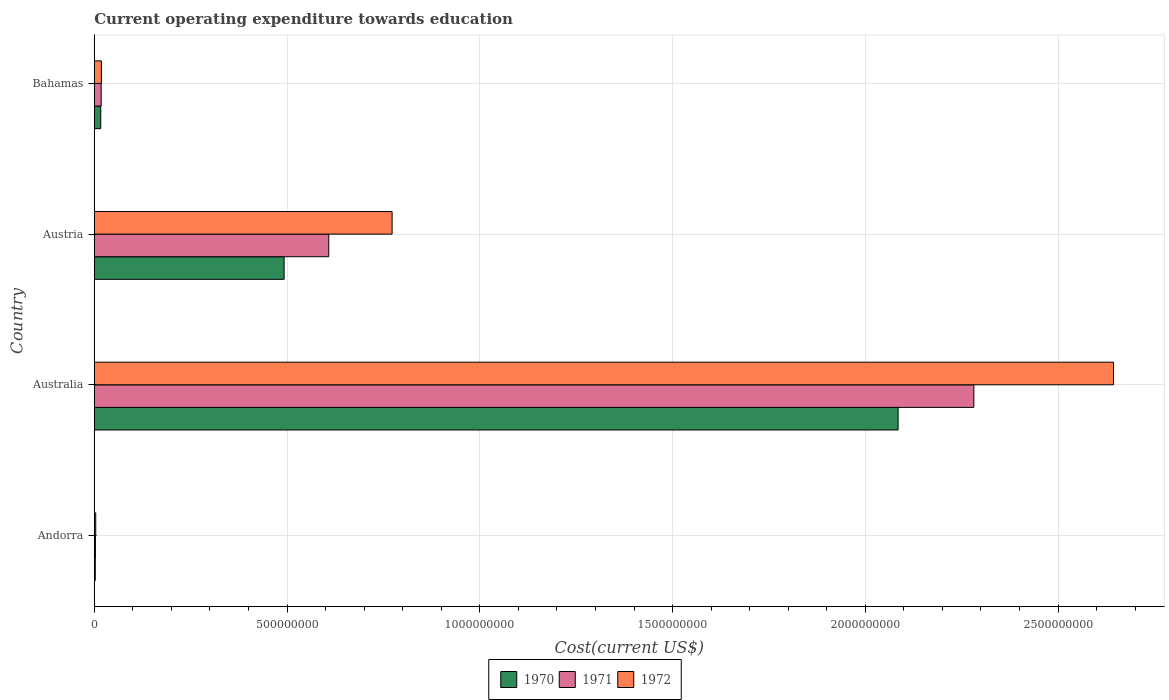How many different coloured bars are there?
Give a very brief answer. 3. How many groups of bars are there?
Your answer should be compact. 4. Are the number of bars per tick equal to the number of legend labels?
Your answer should be compact. Yes. Are the number of bars on each tick of the Y-axis equal?
Give a very brief answer. Yes. How many bars are there on the 4th tick from the top?
Your answer should be compact. 3. What is the label of the 1st group of bars from the top?
Your answer should be very brief. Bahamas. What is the expenditure towards education in 1971 in Australia?
Provide a succinct answer. 2.28e+09. Across all countries, what is the maximum expenditure towards education in 1972?
Your answer should be very brief. 2.64e+09. Across all countries, what is the minimum expenditure towards education in 1971?
Keep it short and to the point. 2.95e+06. In which country was the expenditure towards education in 1972 maximum?
Give a very brief answer. Australia. In which country was the expenditure towards education in 1972 minimum?
Your answer should be very brief. Andorra. What is the total expenditure towards education in 1972 in the graph?
Keep it short and to the point. 3.44e+09. What is the difference between the expenditure towards education in 1970 in Andorra and that in Australia?
Your answer should be compact. -2.08e+09. What is the difference between the expenditure towards education in 1970 in Bahamas and the expenditure towards education in 1972 in Australia?
Provide a short and direct response. -2.63e+09. What is the average expenditure towards education in 1970 per country?
Ensure brevity in your answer.  6.49e+08. What is the difference between the expenditure towards education in 1970 and expenditure towards education in 1971 in Austria?
Offer a terse response. -1.16e+08. In how many countries, is the expenditure towards education in 1971 greater than 1800000000 US$?
Provide a short and direct response. 1. What is the ratio of the expenditure towards education in 1972 in Andorra to that in Australia?
Provide a short and direct response. 0. Is the expenditure towards education in 1972 in Andorra less than that in Austria?
Your answer should be compact. Yes. What is the difference between the highest and the second highest expenditure towards education in 1971?
Your response must be concise. 1.67e+09. What is the difference between the highest and the lowest expenditure towards education in 1972?
Provide a succinct answer. 2.64e+09. What does the 1st bar from the bottom in Austria represents?
Your answer should be compact. 1970. How many countries are there in the graph?
Offer a very short reply. 4. What is the difference between two consecutive major ticks on the X-axis?
Give a very brief answer. 5.00e+08. Are the values on the major ticks of X-axis written in scientific E-notation?
Your answer should be very brief. No. Does the graph contain grids?
Provide a short and direct response. Yes. How many legend labels are there?
Make the answer very short. 3. How are the legend labels stacked?
Your answer should be compact. Horizontal. What is the title of the graph?
Your answer should be very brief. Current operating expenditure towards education. Does "1994" appear as one of the legend labels in the graph?
Your answer should be compact. No. What is the label or title of the X-axis?
Make the answer very short. Cost(current US$). What is the Cost(current US$) of 1970 in Andorra?
Give a very brief answer. 2.59e+06. What is the Cost(current US$) in 1971 in Andorra?
Offer a very short reply. 2.95e+06. What is the Cost(current US$) of 1972 in Andorra?
Provide a succinct answer. 3.74e+06. What is the Cost(current US$) of 1970 in Australia?
Provide a succinct answer. 2.09e+09. What is the Cost(current US$) of 1971 in Australia?
Your answer should be compact. 2.28e+09. What is the Cost(current US$) in 1972 in Australia?
Provide a succinct answer. 2.64e+09. What is the Cost(current US$) of 1970 in Austria?
Your response must be concise. 4.92e+08. What is the Cost(current US$) of 1971 in Austria?
Offer a terse response. 6.08e+08. What is the Cost(current US$) of 1972 in Austria?
Make the answer very short. 7.73e+08. What is the Cost(current US$) in 1970 in Bahamas?
Your answer should be compact. 1.68e+07. What is the Cost(current US$) in 1971 in Bahamas?
Your answer should be very brief. 1.79e+07. What is the Cost(current US$) in 1972 in Bahamas?
Provide a succinct answer. 1.85e+07. Across all countries, what is the maximum Cost(current US$) of 1970?
Ensure brevity in your answer.  2.09e+09. Across all countries, what is the maximum Cost(current US$) of 1971?
Your answer should be compact. 2.28e+09. Across all countries, what is the maximum Cost(current US$) in 1972?
Offer a terse response. 2.64e+09. Across all countries, what is the minimum Cost(current US$) in 1970?
Ensure brevity in your answer.  2.59e+06. Across all countries, what is the minimum Cost(current US$) of 1971?
Offer a very short reply. 2.95e+06. Across all countries, what is the minimum Cost(current US$) in 1972?
Ensure brevity in your answer.  3.74e+06. What is the total Cost(current US$) of 1970 in the graph?
Provide a succinct answer. 2.60e+09. What is the total Cost(current US$) of 1971 in the graph?
Make the answer very short. 2.91e+09. What is the total Cost(current US$) of 1972 in the graph?
Your answer should be compact. 3.44e+09. What is the difference between the Cost(current US$) in 1970 in Andorra and that in Australia?
Your response must be concise. -2.08e+09. What is the difference between the Cost(current US$) in 1971 in Andorra and that in Australia?
Give a very brief answer. -2.28e+09. What is the difference between the Cost(current US$) in 1972 in Andorra and that in Australia?
Offer a very short reply. -2.64e+09. What is the difference between the Cost(current US$) of 1970 in Andorra and that in Austria?
Offer a very short reply. -4.90e+08. What is the difference between the Cost(current US$) of 1971 in Andorra and that in Austria?
Offer a very short reply. -6.05e+08. What is the difference between the Cost(current US$) of 1972 in Andorra and that in Austria?
Your response must be concise. -7.69e+08. What is the difference between the Cost(current US$) in 1970 in Andorra and that in Bahamas?
Your answer should be very brief. -1.42e+07. What is the difference between the Cost(current US$) in 1971 in Andorra and that in Bahamas?
Offer a very short reply. -1.50e+07. What is the difference between the Cost(current US$) of 1972 in Andorra and that in Bahamas?
Give a very brief answer. -1.47e+07. What is the difference between the Cost(current US$) of 1970 in Australia and that in Austria?
Keep it short and to the point. 1.59e+09. What is the difference between the Cost(current US$) in 1971 in Australia and that in Austria?
Make the answer very short. 1.67e+09. What is the difference between the Cost(current US$) of 1972 in Australia and that in Austria?
Your response must be concise. 1.87e+09. What is the difference between the Cost(current US$) of 1970 in Australia and that in Bahamas?
Provide a short and direct response. 2.07e+09. What is the difference between the Cost(current US$) of 1971 in Australia and that in Bahamas?
Provide a short and direct response. 2.26e+09. What is the difference between the Cost(current US$) of 1972 in Australia and that in Bahamas?
Your response must be concise. 2.63e+09. What is the difference between the Cost(current US$) of 1970 in Austria and that in Bahamas?
Make the answer very short. 4.76e+08. What is the difference between the Cost(current US$) of 1971 in Austria and that in Bahamas?
Provide a short and direct response. 5.90e+08. What is the difference between the Cost(current US$) of 1972 in Austria and that in Bahamas?
Offer a very short reply. 7.54e+08. What is the difference between the Cost(current US$) in 1970 in Andorra and the Cost(current US$) in 1971 in Australia?
Your answer should be very brief. -2.28e+09. What is the difference between the Cost(current US$) in 1970 in Andorra and the Cost(current US$) in 1972 in Australia?
Offer a very short reply. -2.64e+09. What is the difference between the Cost(current US$) in 1971 in Andorra and the Cost(current US$) in 1972 in Australia?
Provide a succinct answer. -2.64e+09. What is the difference between the Cost(current US$) of 1970 in Andorra and the Cost(current US$) of 1971 in Austria?
Offer a terse response. -6.06e+08. What is the difference between the Cost(current US$) in 1970 in Andorra and the Cost(current US$) in 1972 in Austria?
Give a very brief answer. -7.70e+08. What is the difference between the Cost(current US$) in 1971 in Andorra and the Cost(current US$) in 1972 in Austria?
Keep it short and to the point. -7.70e+08. What is the difference between the Cost(current US$) in 1970 in Andorra and the Cost(current US$) in 1971 in Bahamas?
Provide a succinct answer. -1.53e+07. What is the difference between the Cost(current US$) of 1970 in Andorra and the Cost(current US$) of 1972 in Bahamas?
Your answer should be compact. -1.59e+07. What is the difference between the Cost(current US$) in 1971 in Andorra and the Cost(current US$) in 1972 in Bahamas?
Keep it short and to the point. -1.55e+07. What is the difference between the Cost(current US$) in 1970 in Australia and the Cost(current US$) in 1971 in Austria?
Give a very brief answer. 1.48e+09. What is the difference between the Cost(current US$) in 1970 in Australia and the Cost(current US$) in 1972 in Austria?
Keep it short and to the point. 1.31e+09. What is the difference between the Cost(current US$) in 1971 in Australia and the Cost(current US$) in 1972 in Austria?
Your response must be concise. 1.51e+09. What is the difference between the Cost(current US$) in 1970 in Australia and the Cost(current US$) in 1971 in Bahamas?
Your answer should be compact. 2.07e+09. What is the difference between the Cost(current US$) in 1970 in Australia and the Cost(current US$) in 1972 in Bahamas?
Give a very brief answer. 2.07e+09. What is the difference between the Cost(current US$) of 1971 in Australia and the Cost(current US$) of 1972 in Bahamas?
Offer a terse response. 2.26e+09. What is the difference between the Cost(current US$) in 1970 in Austria and the Cost(current US$) in 1971 in Bahamas?
Provide a short and direct response. 4.74e+08. What is the difference between the Cost(current US$) in 1970 in Austria and the Cost(current US$) in 1972 in Bahamas?
Offer a terse response. 4.74e+08. What is the difference between the Cost(current US$) in 1971 in Austria and the Cost(current US$) in 1972 in Bahamas?
Keep it short and to the point. 5.90e+08. What is the average Cost(current US$) in 1970 per country?
Provide a succinct answer. 6.49e+08. What is the average Cost(current US$) in 1971 per country?
Ensure brevity in your answer.  7.28e+08. What is the average Cost(current US$) in 1972 per country?
Give a very brief answer. 8.60e+08. What is the difference between the Cost(current US$) in 1970 and Cost(current US$) in 1971 in Andorra?
Offer a very short reply. -3.56e+05. What is the difference between the Cost(current US$) of 1970 and Cost(current US$) of 1972 in Andorra?
Offer a very short reply. -1.15e+06. What is the difference between the Cost(current US$) in 1971 and Cost(current US$) in 1972 in Andorra?
Offer a very short reply. -7.92e+05. What is the difference between the Cost(current US$) of 1970 and Cost(current US$) of 1971 in Australia?
Your response must be concise. -1.96e+08. What is the difference between the Cost(current US$) of 1970 and Cost(current US$) of 1972 in Australia?
Provide a succinct answer. -5.59e+08. What is the difference between the Cost(current US$) in 1971 and Cost(current US$) in 1972 in Australia?
Your answer should be compact. -3.62e+08. What is the difference between the Cost(current US$) of 1970 and Cost(current US$) of 1971 in Austria?
Make the answer very short. -1.16e+08. What is the difference between the Cost(current US$) of 1970 and Cost(current US$) of 1972 in Austria?
Provide a succinct answer. -2.80e+08. What is the difference between the Cost(current US$) in 1971 and Cost(current US$) in 1972 in Austria?
Your response must be concise. -1.64e+08. What is the difference between the Cost(current US$) of 1970 and Cost(current US$) of 1971 in Bahamas?
Give a very brief answer. -1.09e+06. What is the difference between the Cost(current US$) in 1970 and Cost(current US$) in 1972 in Bahamas?
Ensure brevity in your answer.  -1.64e+06. What is the difference between the Cost(current US$) of 1971 and Cost(current US$) of 1972 in Bahamas?
Offer a very short reply. -5.46e+05. What is the ratio of the Cost(current US$) of 1970 in Andorra to that in Australia?
Make the answer very short. 0. What is the ratio of the Cost(current US$) of 1971 in Andorra to that in Australia?
Your answer should be compact. 0. What is the ratio of the Cost(current US$) in 1972 in Andorra to that in Australia?
Provide a succinct answer. 0. What is the ratio of the Cost(current US$) of 1970 in Andorra to that in Austria?
Your response must be concise. 0.01. What is the ratio of the Cost(current US$) of 1971 in Andorra to that in Austria?
Your response must be concise. 0. What is the ratio of the Cost(current US$) of 1972 in Andorra to that in Austria?
Offer a terse response. 0. What is the ratio of the Cost(current US$) in 1970 in Andorra to that in Bahamas?
Give a very brief answer. 0.15. What is the ratio of the Cost(current US$) in 1971 in Andorra to that in Bahamas?
Keep it short and to the point. 0.16. What is the ratio of the Cost(current US$) in 1972 in Andorra to that in Bahamas?
Give a very brief answer. 0.2. What is the ratio of the Cost(current US$) of 1970 in Australia to that in Austria?
Offer a very short reply. 4.23. What is the ratio of the Cost(current US$) of 1971 in Australia to that in Austria?
Provide a short and direct response. 3.75. What is the ratio of the Cost(current US$) in 1972 in Australia to that in Austria?
Make the answer very short. 3.42. What is the ratio of the Cost(current US$) of 1970 in Australia to that in Bahamas?
Your response must be concise. 124.02. What is the ratio of the Cost(current US$) of 1971 in Australia to that in Bahamas?
Your answer should be very brief. 127.42. What is the ratio of the Cost(current US$) in 1972 in Australia to that in Bahamas?
Provide a succinct answer. 143.29. What is the ratio of the Cost(current US$) in 1970 in Austria to that in Bahamas?
Give a very brief answer. 29.29. What is the ratio of the Cost(current US$) in 1971 in Austria to that in Bahamas?
Make the answer very short. 33.97. What is the ratio of the Cost(current US$) in 1972 in Austria to that in Bahamas?
Keep it short and to the point. 41.87. What is the difference between the highest and the second highest Cost(current US$) of 1970?
Make the answer very short. 1.59e+09. What is the difference between the highest and the second highest Cost(current US$) in 1971?
Provide a short and direct response. 1.67e+09. What is the difference between the highest and the second highest Cost(current US$) of 1972?
Your answer should be very brief. 1.87e+09. What is the difference between the highest and the lowest Cost(current US$) of 1970?
Your response must be concise. 2.08e+09. What is the difference between the highest and the lowest Cost(current US$) in 1971?
Provide a succinct answer. 2.28e+09. What is the difference between the highest and the lowest Cost(current US$) in 1972?
Offer a terse response. 2.64e+09. 